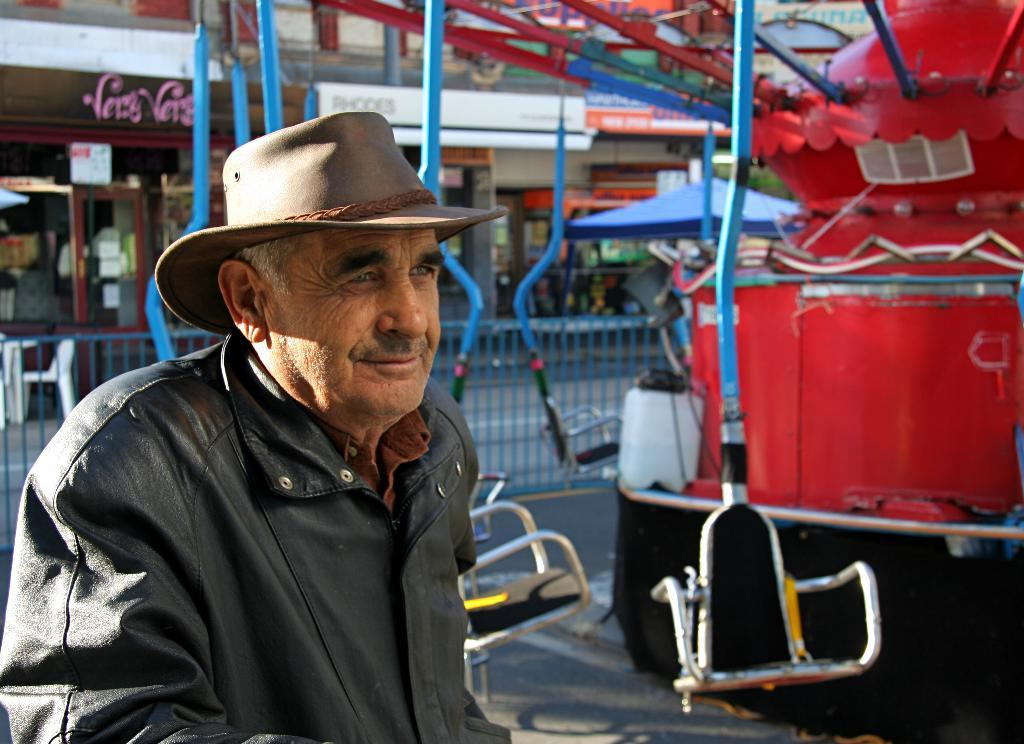Who is present in the image? There is a man in the image. What is the man wearing on his upper body? The man is wearing a black jacket. What type of headwear is the man wearing? The man is wearing a brown hat. What can be seen in the background of the image? There are shops visible in the image. What type of development is taking place in the image? There is no development taking place in the image; it features a man wearing a black jacket and a brown hat, with shops visible in the background. 